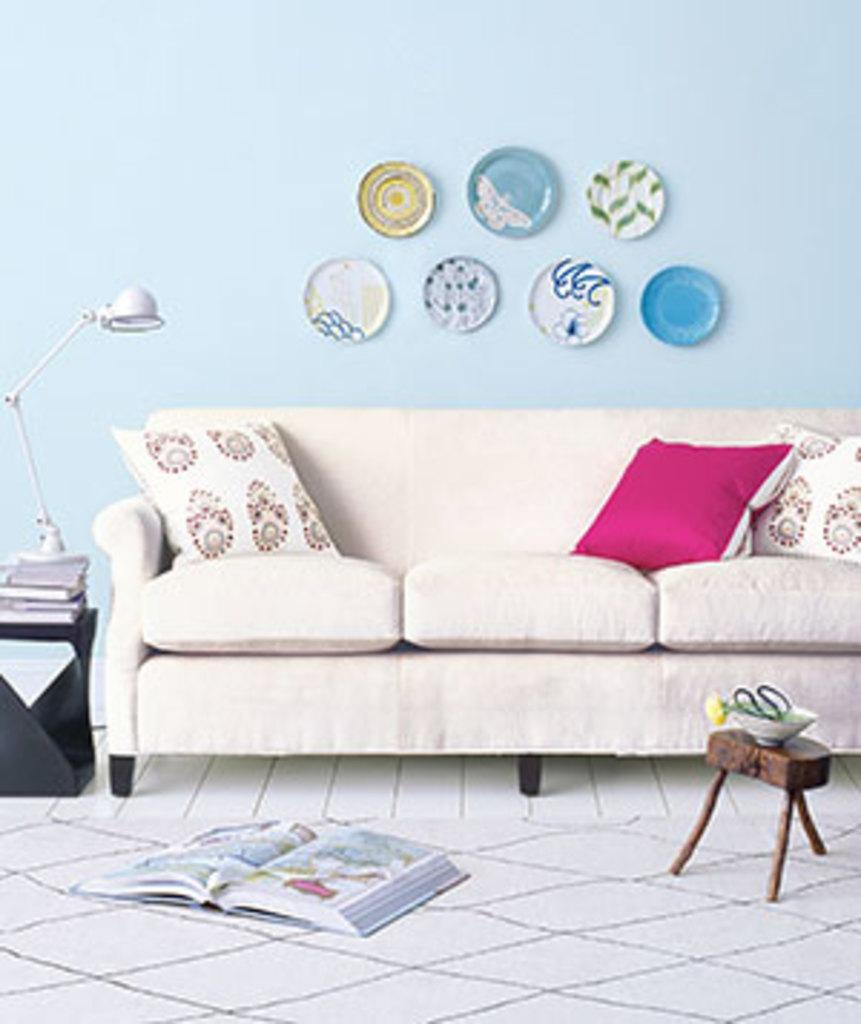Where was the image taken? The image was taken inside a room. What is the main piece of furniture in the room? There is a sofa in the middle of the room. What is placed on the sofa? There are pillows on the sofa. What decorations can be seen on the wall? There are plates sticker on the wall. Where is the light source in the room? There is a light with a stand to the left. What type of hat is the pig wearing in the image? There is no pig or hat present in the image. 